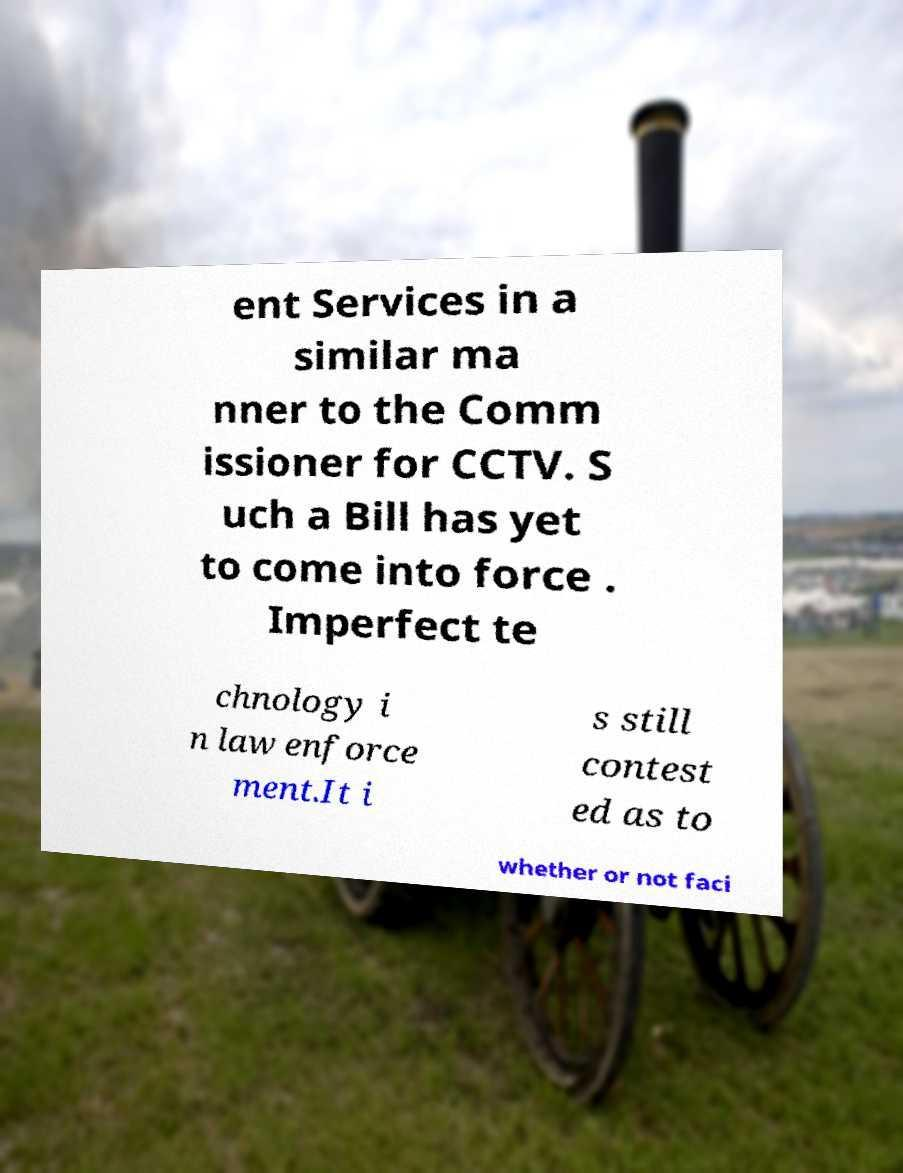Can you accurately transcribe the text from the provided image for me? ent Services in a similar ma nner to the Comm issioner for CCTV. S uch a Bill has yet to come into force . Imperfect te chnology i n law enforce ment.It i s still contest ed as to whether or not faci 